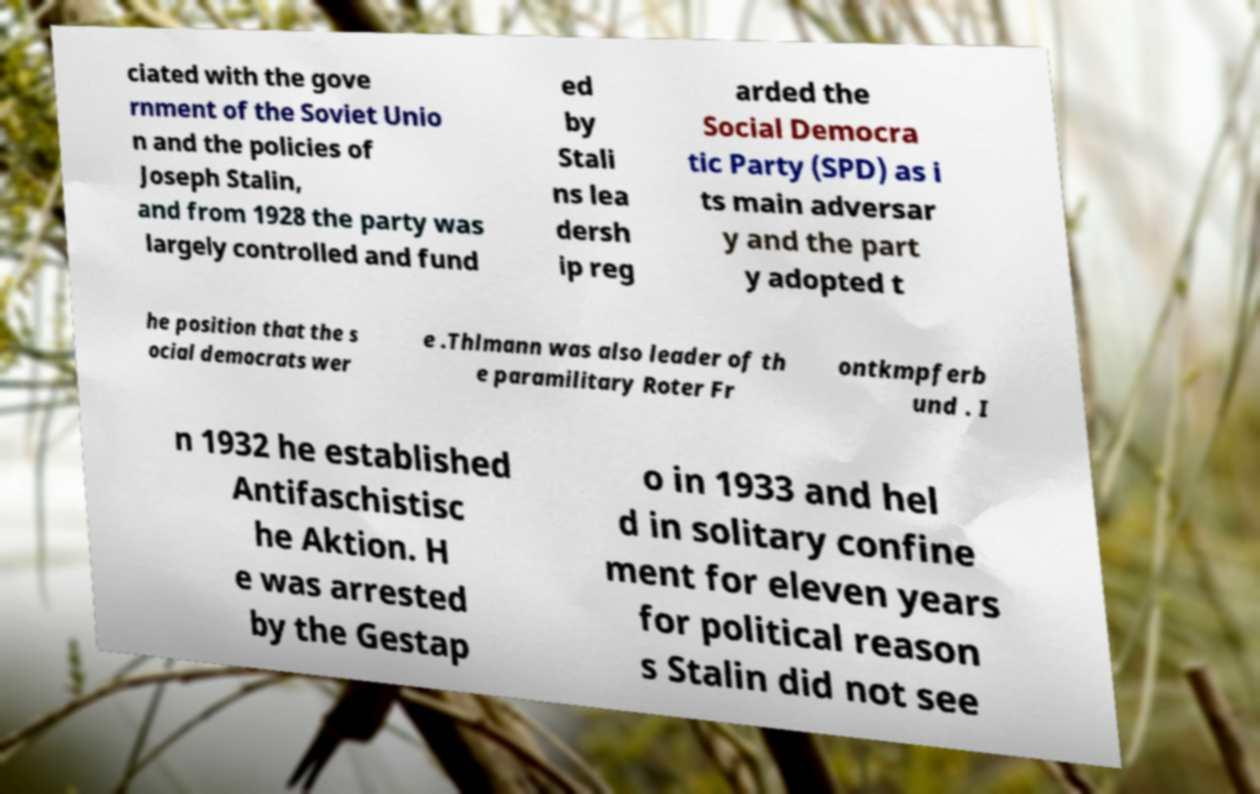Can you read and provide the text displayed in the image?This photo seems to have some interesting text. Can you extract and type it out for me? ciated with the gove rnment of the Soviet Unio n and the policies of Joseph Stalin, and from 1928 the party was largely controlled and fund ed by Stali ns lea dersh ip reg arded the Social Democra tic Party (SPD) as i ts main adversar y and the part y adopted t he position that the s ocial democrats wer e .Thlmann was also leader of th e paramilitary Roter Fr ontkmpferb und . I n 1932 he established Antifaschistisc he Aktion. H e was arrested by the Gestap o in 1933 and hel d in solitary confine ment for eleven years for political reason s Stalin did not see 